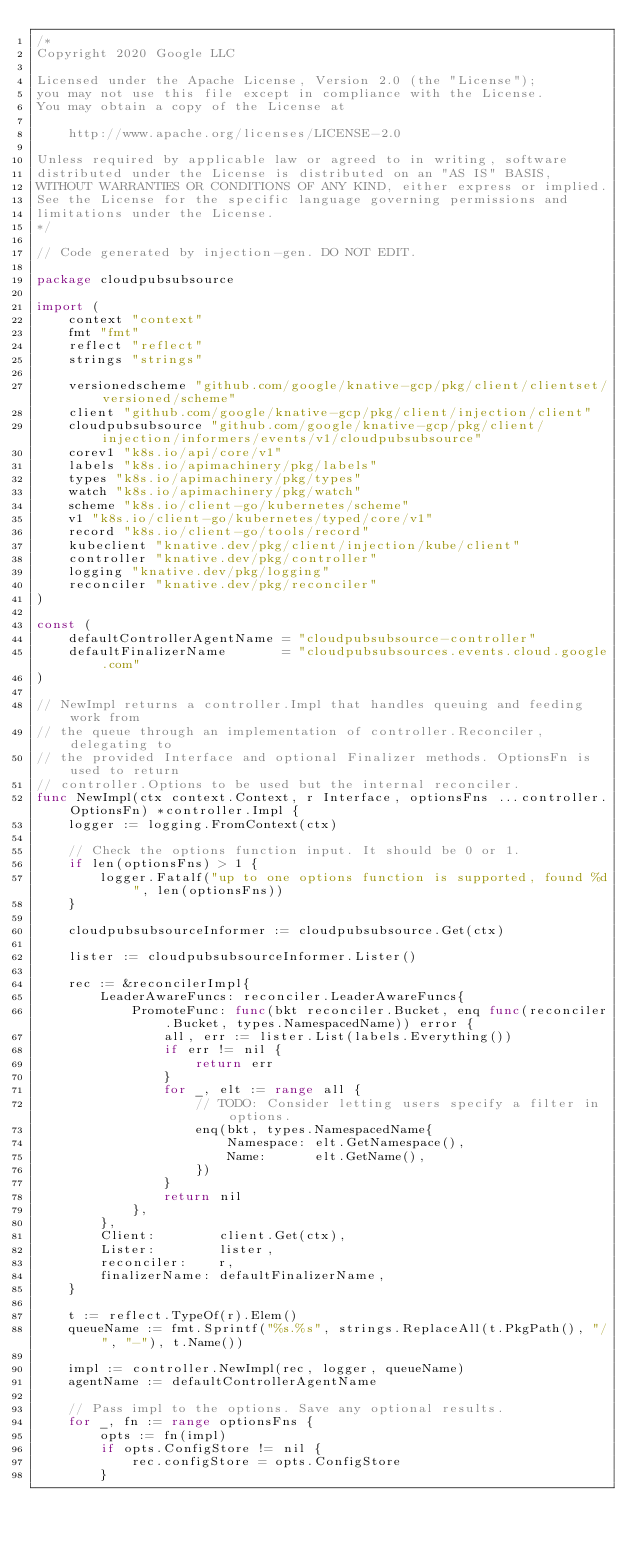<code> <loc_0><loc_0><loc_500><loc_500><_Go_>/*
Copyright 2020 Google LLC

Licensed under the Apache License, Version 2.0 (the "License");
you may not use this file except in compliance with the License.
You may obtain a copy of the License at

    http://www.apache.org/licenses/LICENSE-2.0

Unless required by applicable law or agreed to in writing, software
distributed under the License is distributed on an "AS IS" BASIS,
WITHOUT WARRANTIES OR CONDITIONS OF ANY KIND, either express or implied.
See the License for the specific language governing permissions and
limitations under the License.
*/

// Code generated by injection-gen. DO NOT EDIT.

package cloudpubsubsource

import (
	context "context"
	fmt "fmt"
	reflect "reflect"
	strings "strings"

	versionedscheme "github.com/google/knative-gcp/pkg/client/clientset/versioned/scheme"
	client "github.com/google/knative-gcp/pkg/client/injection/client"
	cloudpubsubsource "github.com/google/knative-gcp/pkg/client/injection/informers/events/v1/cloudpubsubsource"
	corev1 "k8s.io/api/core/v1"
	labels "k8s.io/apimachinery/pkg/labels"
	types "k8s.io/apimachinery/pkg/types"
	watch "k8s.io/apimachinery/pkg/watch"
	scheme "k8s.io/client-go/kubernetes/scheme"
	v1 "k8s.io/client-go/kubernetes/typed/core/v1"
	record "k8s.io/client-go/tools/record"
	kubeclient "knative.dev/pkg/client/injection/kube/client"
	controller "knative.dev/pkg/controller"
	logging "knative.dev/pkg/logging"
	reconciler "knative.dev/pkg/reconciler"
)

const (
	defaultControllerAgentName = "cloudpubsubsource-controller"
	defaultFinalizerName       = "cloudpubsubsources.events.cloud.google.com"
)

// NewImpl returns a controller.Impl that handles queuing and feeding work from
// the queue through an implementation of controller.Reconciler, delegating to
// the provided Interface and optional Finalizer methods. OptionsFn is used to return
// controller.Options to be used but the internal reconciler.
func NewImpl(ctx context.Context, r Interface, optionsFns ...controller.OptionsFn) *controller.Impl {
	logger := logging.FromContext(ctx)

	// Check the options function input. It should be 0 or 1.
	if len(optionsFns) > 1 {
		logger.Fatalf("up to one options function is supported, found %d", len(optionsFns))
	}

	cloudpubsubsourceInformer := cloudpubsubsource.Get(ctx)

	lister := cloudpubsubsourceInformer.Lister()

	rec := &reconcilerImpl{
		LeaderAwareFuncs: reconciler.LeaderAwareFuncs{
			PromoteFunc: func(bkt reconciler.Bucket, enq func(reconciler.Bucket, types.NamespacedName)) error {
				all, err := lister.List(labels.Everything())
				if err != nil {
					return err
				}
				for _, elt := range all {
					// TODO: Consider letting users specify a filter in options.
					enq(bkt, types.NamespacedName{
						Namespace: elt.GetNamespace(),
						Name:      elt.GetName(),
					})
				}
				return nil
			},
		},
		Client:        client.Get(ctx),
		Lister:        lister,
		reconciler:    r,
		finalizerName: defaultFinalizerName,
	}

	t := reflect.TypeOf(r).Elem()
	queueName := fmt.Sprintf("%s.%s", strings.ReplaceAll(t.PkgPath(), "/", "-"), t.Name())

	impl := controller.NewImpl(rec, logger, queueName)
	agentName := defaultControllerAgentName

	// Pass impl to the options. Save any optional results.
	for _, fn := range optionsFns {
		opts := fn(impl)
		if opts.ConfigStore != nil {
			rec.configStore = opts.ConfigStore
		}</code> 